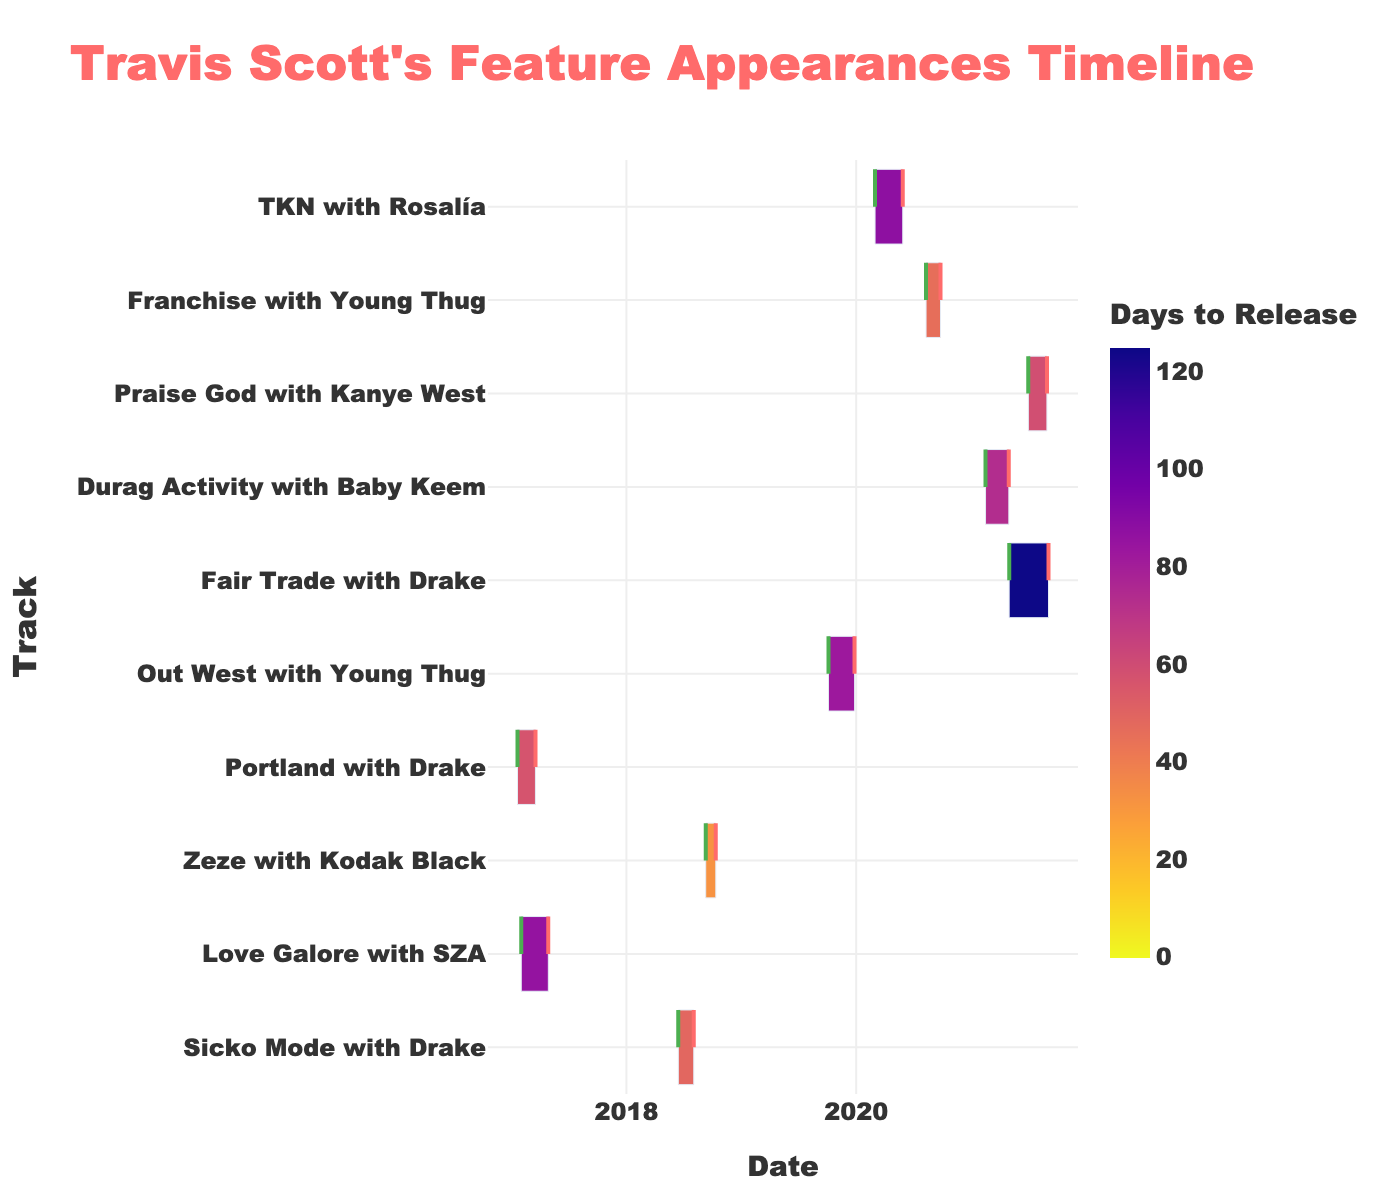Which track took the longest to release after recording? By comparing the "Days to Release" color scale bar, we can see that "Fair Trade" with Drake has the darkest shade, indicating the longest duration between recording and release.
Answer: "Fair Trade" with Drake How many days did it take to release "Sicko Mode"? The Gantt chart color scale shows the "Days to Release" of "Sicko Mode." By checking the color tone and matching it to the color bar, we can see it took 49 days.
Answer: 49 days Which track was recorded and released in the shortest period? By looking at the color of the shortest duration on the color scale, "Praise God" with Kanye West should have the lightest tone, indicating it took the least time.
Answer: "Praise God" with Kanye West What is the title of the chart shown? The title is directly written at the top of the chart, "Travis Scott's Feature Appearances Timeline."
Answer: Travis Scott's Feature Appearances Timeline Which two tracks were both recorded and released in 2020? Looking at the X-axis date range and matching it with the track names in the chart, "Franchise" with Young Thug and "TKN" with Rosalía both fall within the year 2020.
Answer: "Franchise" with Young Thug and "TKN" with Rosalía What is the average duration (in days) from recording to release for all tracks? Summing each track's duration from the color scale and dividing by the number of tracks: (49 + 86 + 32 + 57 + 83 + 125 + 74 + 59 + 46 + 88) / 10 = 69.9 days.
Answer: 69.9 days Which track was recorded the earliest? By checking the earliest date on the X-axis and aligning it with the track, "Portland" with Drake was recorded first on 2017-01-20.
Answer: "Portland" with Drake How many days did it take to release "Fair Trade"? Checking the color bar next to "Fair Trade" with Drake and matching it to the scale reveals it took 125 days, the darkest tone.
Answer: 125 days What color represents the maximum number of days to release? The darkest tone on the color scale visually represents the maximum days to release, indicating a deep color from Plasma_r color scale.
Answer: Darkest color Which track was released closest to "Fair Trade"? By checking the ending dates and proximity of intervals near "Fair Trade" with Drake on the timeline, "Praise God" with Kanye West has a close release date.
Answer: "Praise God" with Kanye West 